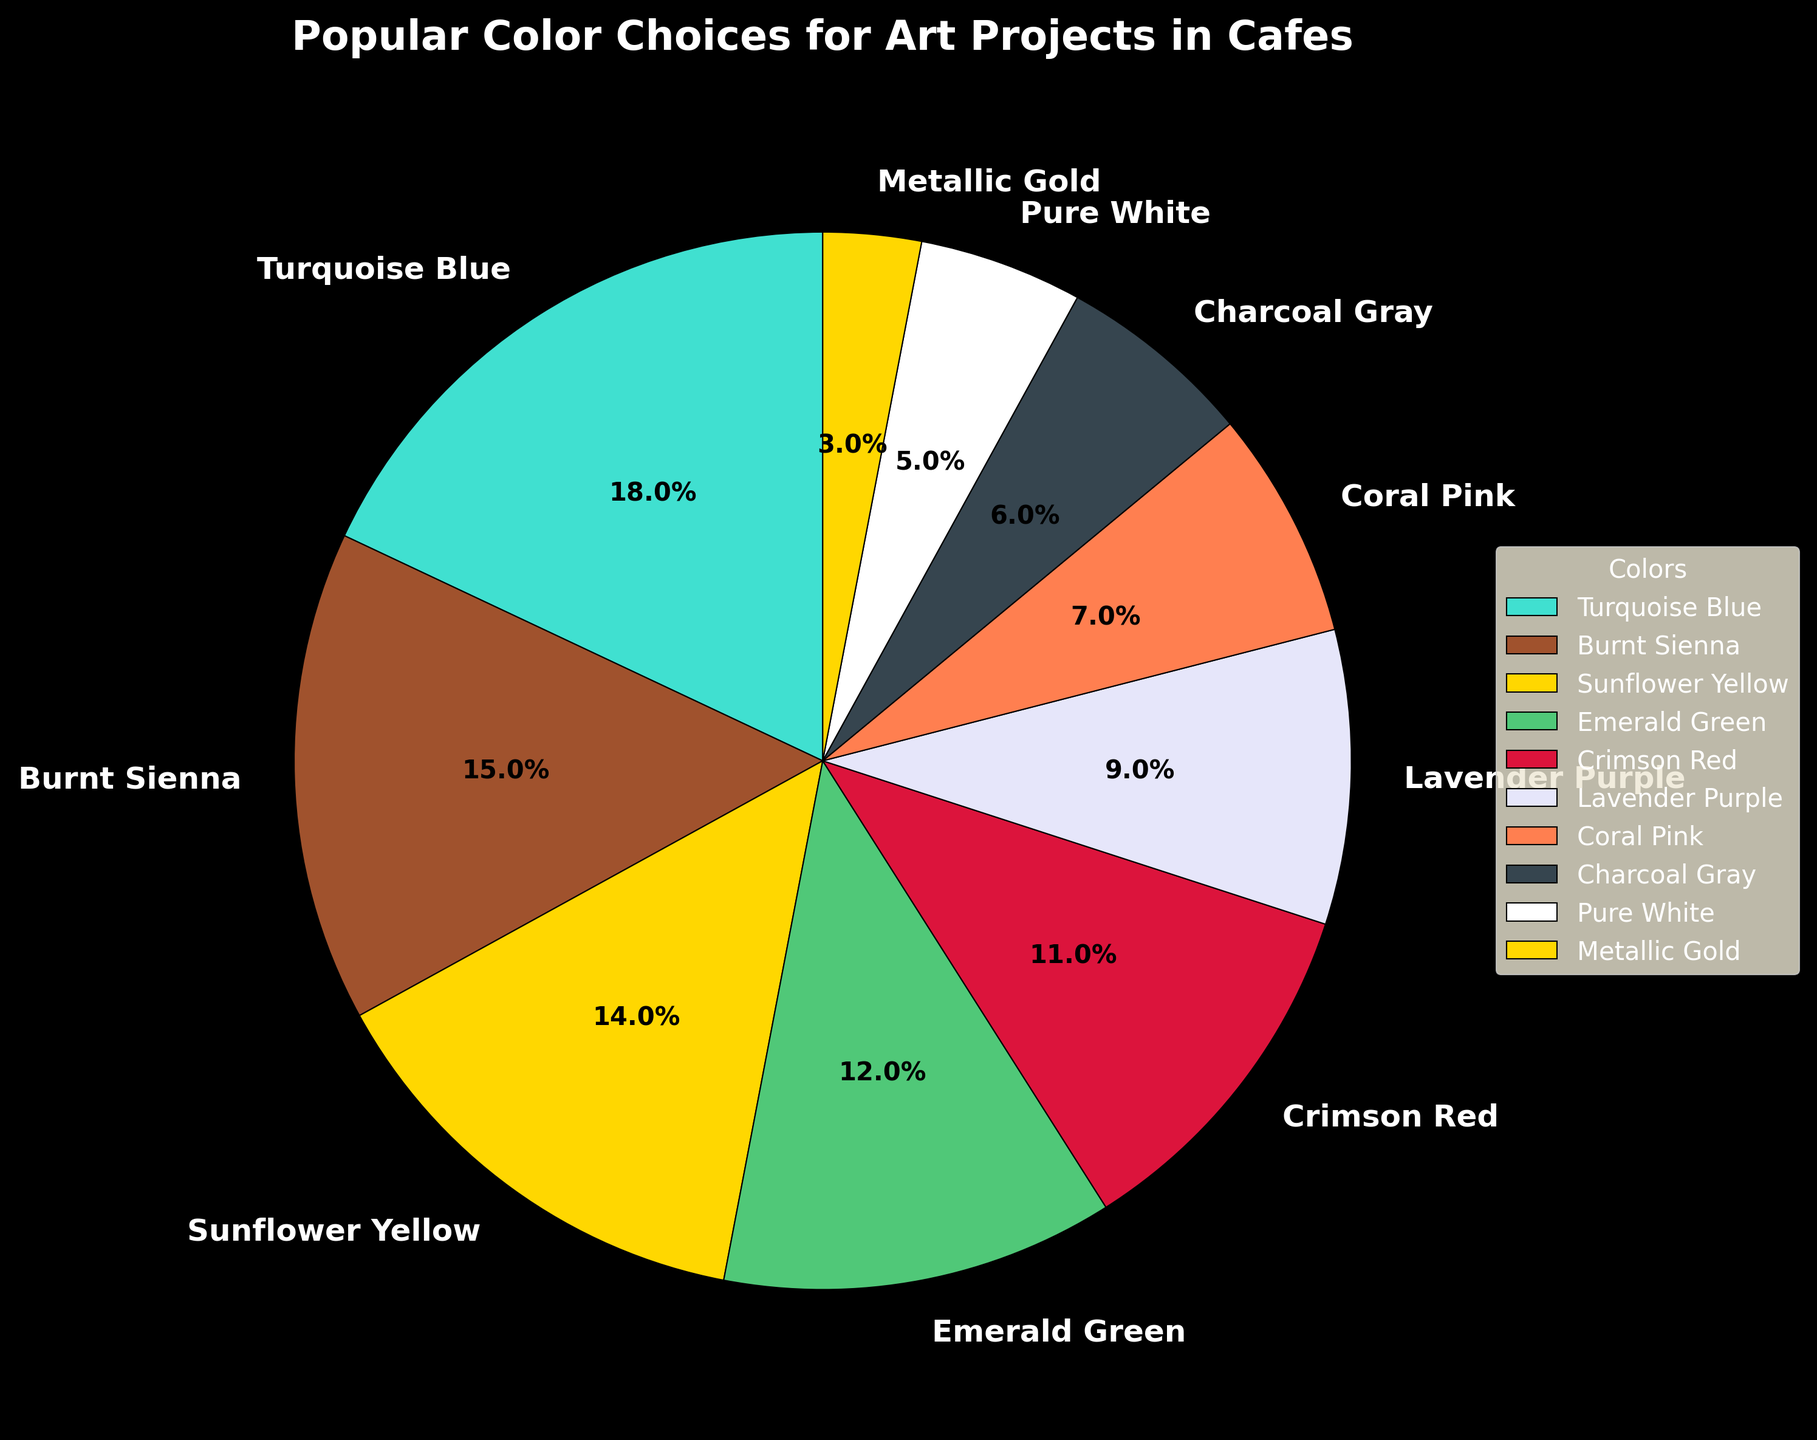What is the most popular color choice for art projects in cafes? By looking at the pie chart, we can see that the largest segment is Turquoise Blue with 18%.
Answer: Turquoise Blue Which color has a higher percentage, Emerald Green or Sunflower Yellow? By comparing the sizes of the segments, we see that Sunflower Yellow has 14% whereas Emerald Green has 12%.
Answer: Sunflower Yellow What is the combined percentage of the two least popular colors? The two least popular colors are Pure White (5%) and Metallic Gold (3%). Adding them together gives 5% + 3% = 8%.
Answer: 8% Is Coral Pink more popular than Charcoal Gray? By comparing the percentages, Coral Pink (7%) is more popular than Charcoal Gray (6%).
Answer: Yes Which colors constitute more than 10% each of the popular color choices? By examining the pie chart, we can see that Turquoise Blue (18%), Burnt Sienna (15%), Sunflower Yellow (14%), Emerald Green (12%), and Crimson Red (11%) each have more than 10%.
Answer: Turquoise Blue, Burnt Sienna, Sunflower Yellow, Emerald Green, Crimson Red How much more popular is Turquoise Blue compared to Crimson Red? Turquoise Blue has 18% and Crimson Red has 11%. The difference is 18% - 11% = 7%.
Answer: 7% What is the average percentage of Burnt Sienna and Emerald Green? Add the percentages of Burnt Sienna (15%) and Emerald Green (12%) and then divide by 2. (15% + 12%) / 2 = 13.5%.
Answer: 13.5% Which has a larger percentage, Lavender Purple or Coral Pink? Lavender Purple has 9%, while Coral Pink has 7%. Therefore, Lavender Purple has a larger percentage.
Answer: Lavender Purple Is the percentage of Pure White lower than 6%? Pure White has a percentage of 5%, which is lower than 6%.
Answer: Yes 